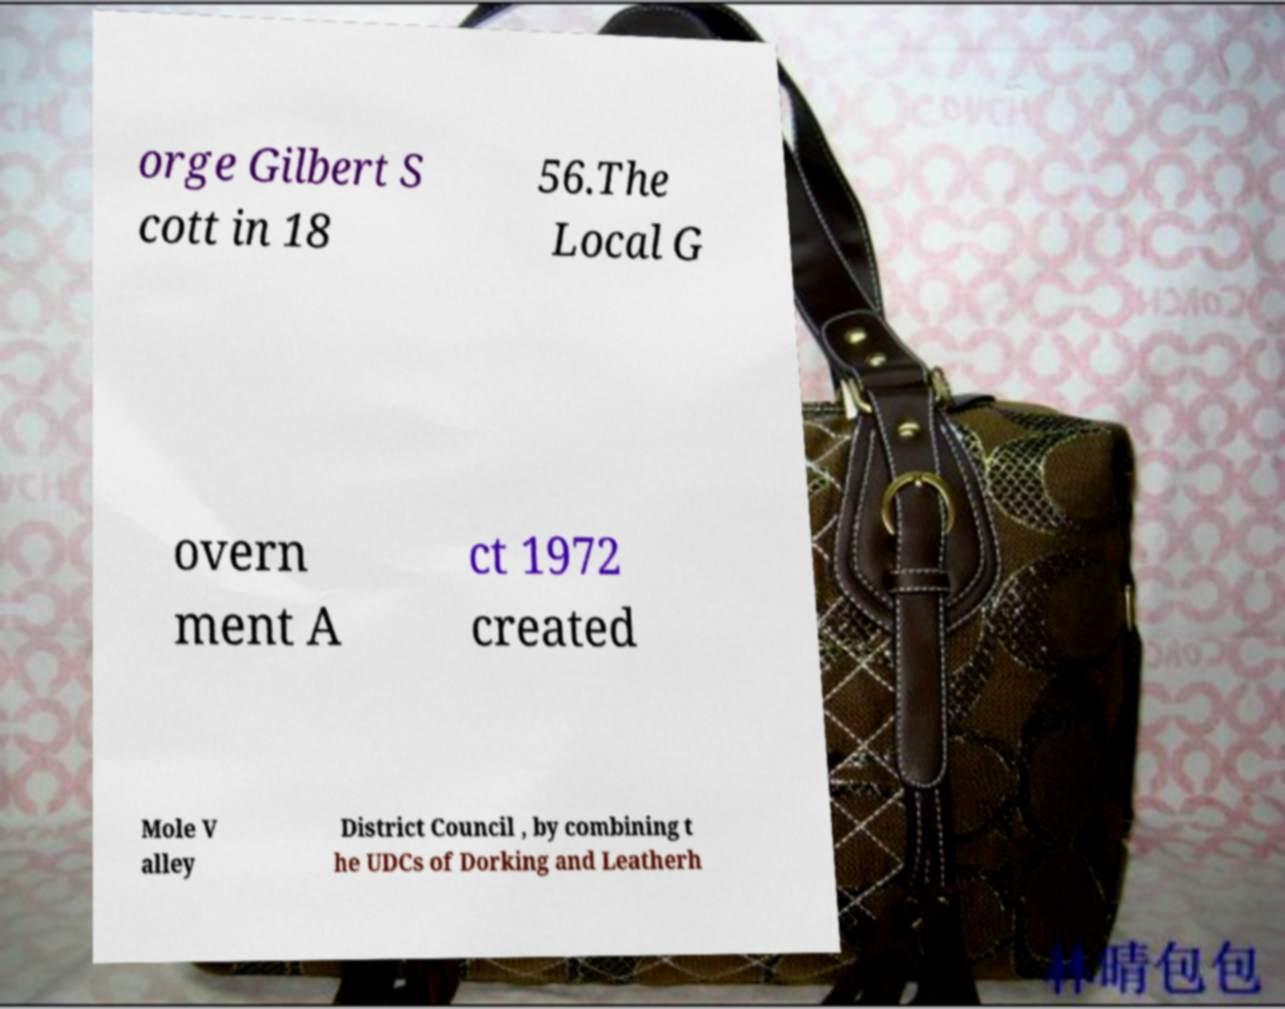Could you extract and type out the text from this image? orge Gilbert S cott in 18 56.The Local G overn ment A ct 1972 created Mole V alley District Council , by combining t he UDCs of Dorking and Leatherh 